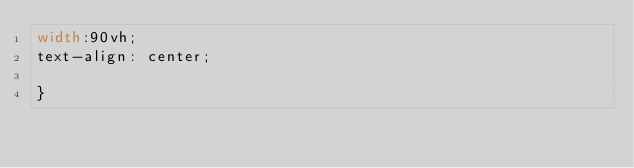<code> <loc_0><loc_0><loc_500><loc_500><_CSS_>width:90vh;
text-align: center;

}
</code> 